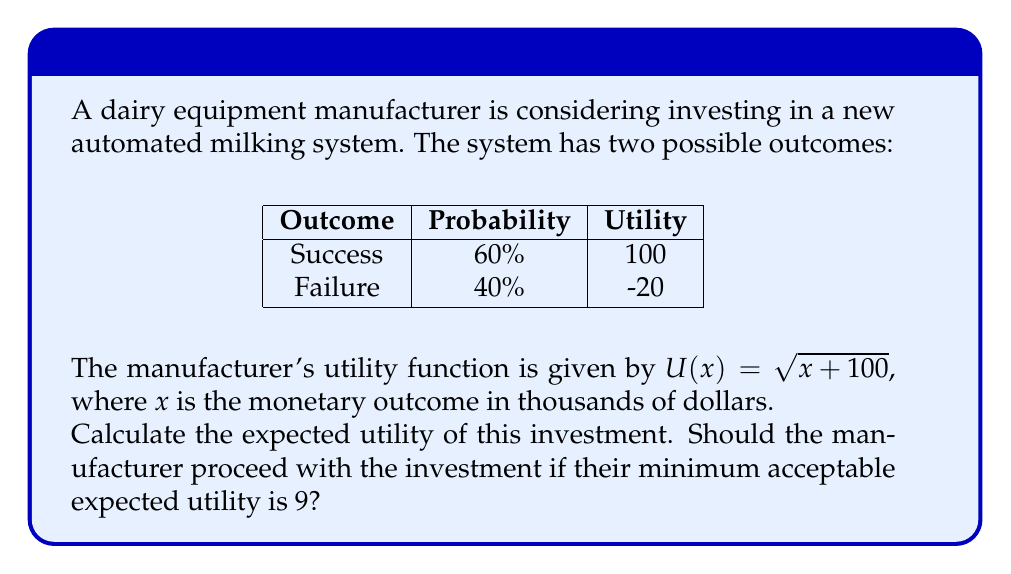Solve this math problem. To solve this problem, we'll use the expected utility theory. Here are the steps:

1) First, we need to calculate the utility for each outcome:

   Success: $U(100) = \sqrt{100 + 100} = \sqrt{200} = 10\sqrt{2}$
   Failure: $U(-20) = \sqrt{-20 + 100} = \sqrt{80} = 4\sqrt{5}$

2) Now, we calculate the expected utility (EU) using the probability-weighted sum of utilities:

   $EU = P(\text{Success}) \cdot U(\text{Success}) + P(\text{Failure}) \cdot U(\text{Failure})$

3) Substituting the values:

   $EU = 0.6 \cdot 10\sqrt{2} + 0.4 \cdot 4\sqrt{5}$

4) Simplifying:

   $EU = 6\sqrt{2} + 1.6\sqrt{5}$

5) To compare with the minimum acceptable expected utility, we need to calculate this value:

   $EU = 6\sqrt{2} + 1.6\sqrt{5} \approx 9.1416$

6) Since 9.1416 > 9, the expected utility is higher than the minimum acceptable level.

Therefore, based on the expected utility theory, the manufacturer should proceed with the investment.
Answer: $6\sqrt{2} + 1.6\sqrt{5}$ (≈ 9.1416); Yes, invest. 